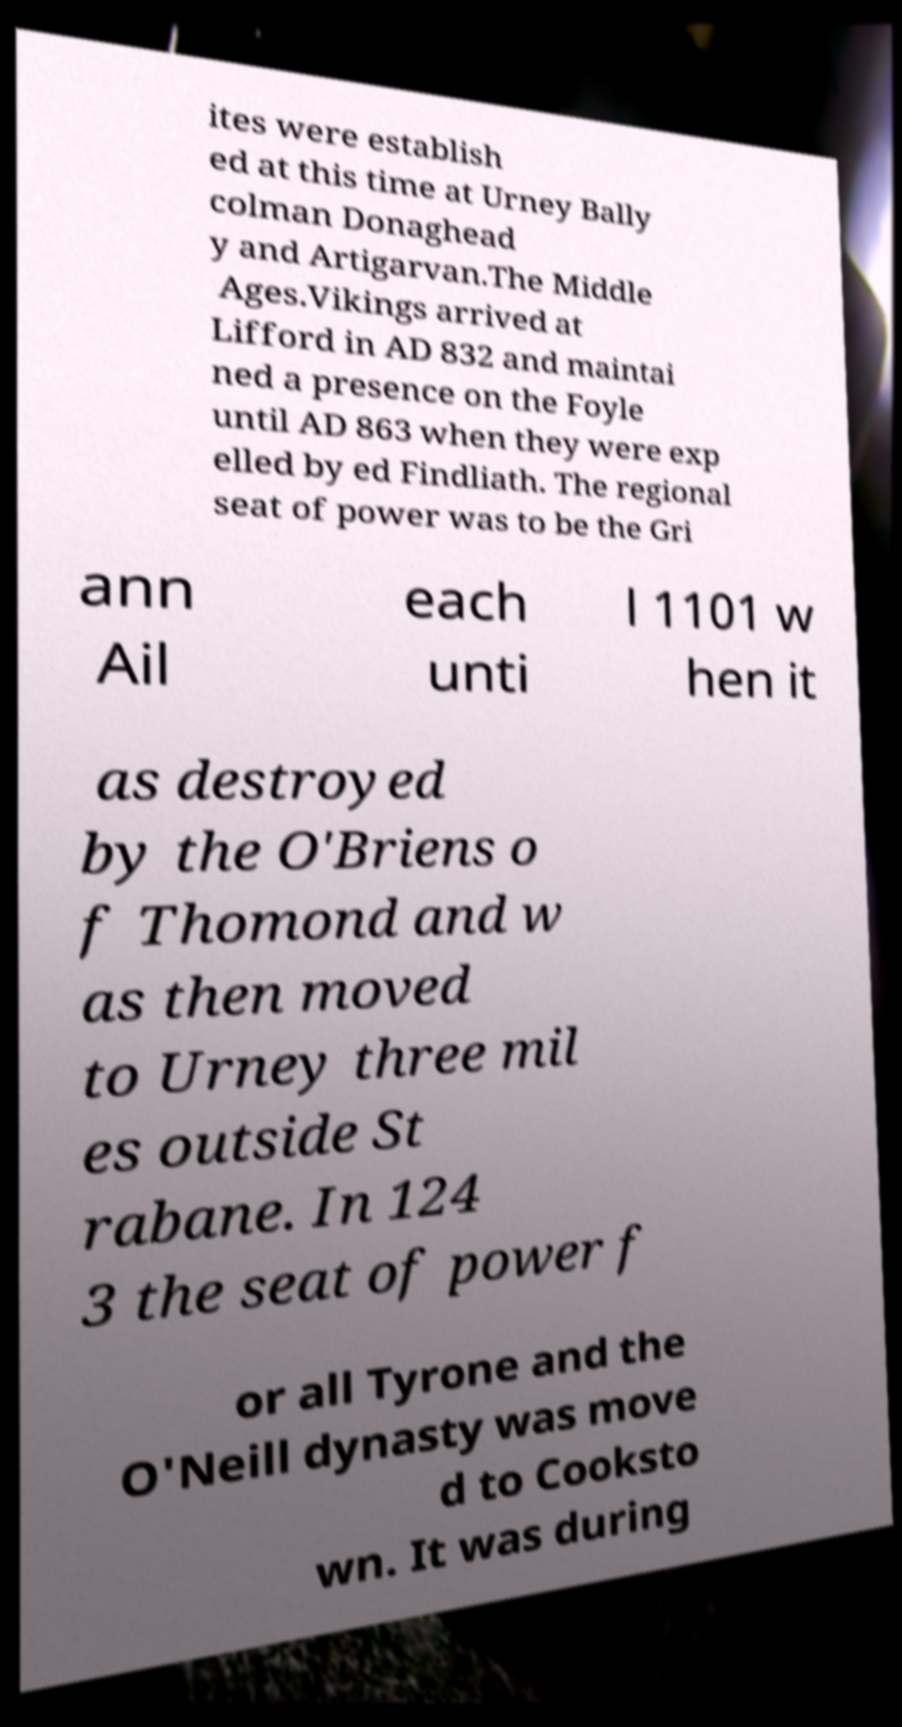Please read and relay the text visible in this image. What does it say? ites were establish ed at this time at Urney Bally colman Donaghead y and Artigarvan.The Middle Ages.Vikings arrived at Lifford in AD 832 and maintai ned a presence on the Foyle until AD 863 when they were exp elled by ed Findliath. The regional seat of power was to be the Gri ann Ail each unti l 1101 w hen it as destroyed by the O'Briens o f Thomond and w as then moved to Urney three mil es outside St rabane. In 124 3 the seat of power f or all Tyrone and the O'Neill dynasty was move d to Cooksto wn. It was during 